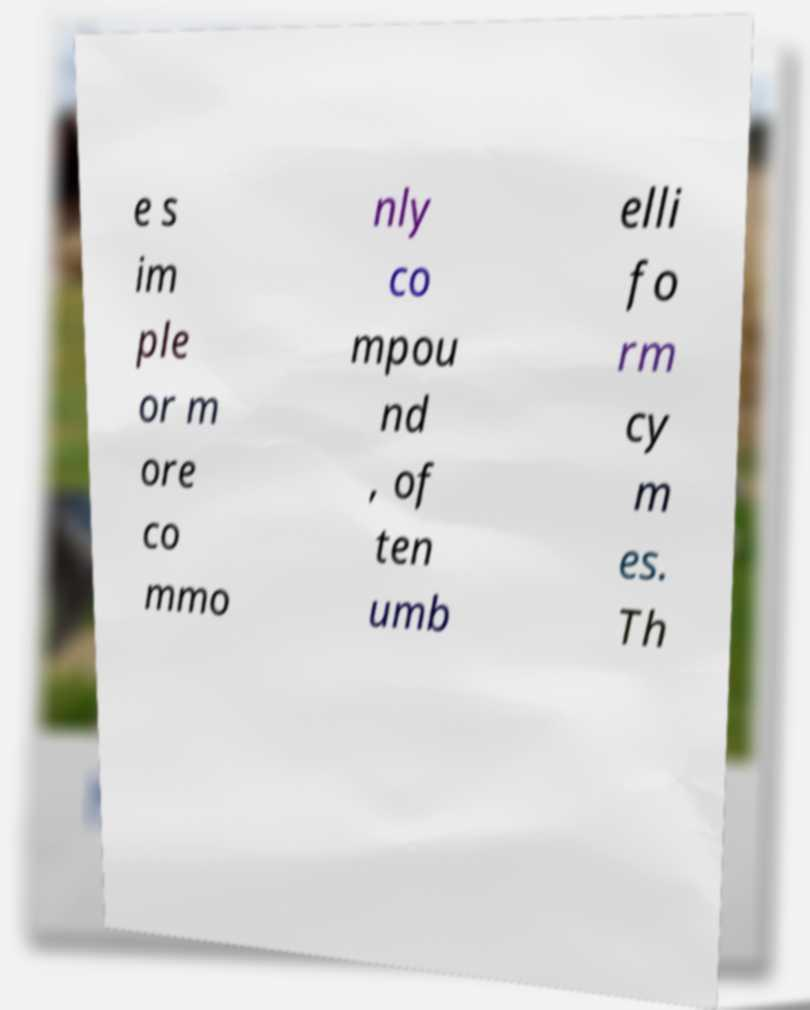Please read and relay the text visible in this image. What does it say? e s im ple or m ore co mmo nly co mpou nd , of ten umb elli fo rm cy m es. Th 